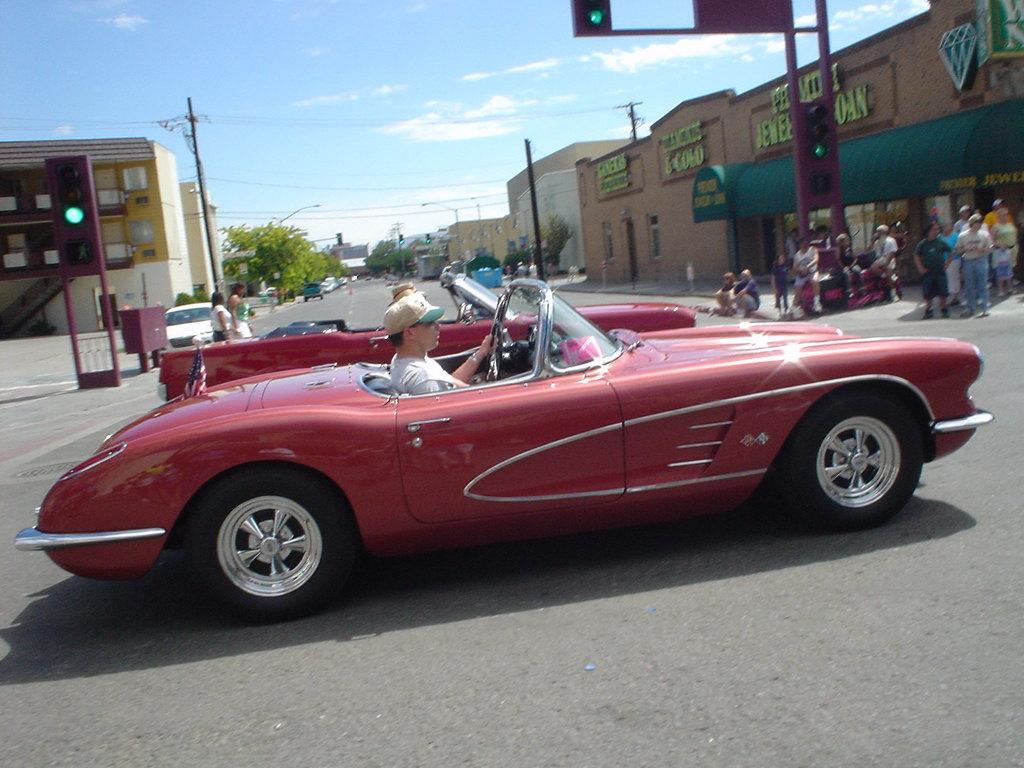In one or two sentences, can you explain what this image depicts? In front of the image there are two people driving cars on the roads, on the either side of the roads there are a few pedestrians walking on the pavement and there are electric poles with cables on it, trees, lamp posts and buildings, on the roads there are some vehicles, beside the road there are trash bins, at the top of the image there are clouds in the sky, on the buildings there are name boards. 